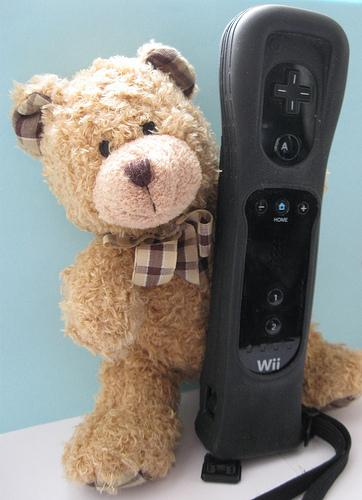What kind of game controller is being held by the bear, and what are its distinctive characteristics? The bear is holding a black wii game controller with a strap, white lettering that says "wii", and a round home button with a blue icon. Mention the various objects in the image along with their colors and specific details. The image consists of a beige teddy bear with plaid ears and a bow tie, a black wii game controller with a strap and white lettering, and a gray wii console. What is the bear wearing around its neck, and describe the bear's other distinct features. The bear is wearing a plaid ribbon around its neck. It has dark button eyes, a brown nose, and plaid ears. Choose an object in the image and talk about its distinguishing characteristics. The black wii game controller has white lettering that says "wii", a round home button with a blue icon, and a black strap. Identify the color and type of the object the bear is holding and describe the bear's appearance. The bear is holding a black wii game controller. It has brown fur, plaid ears, a pink snout, black eyes, and a plaid ribbon. Explain the type of scarf the bear is wearing and describe its appearance. The bear is wearing a plaid ribbon scarf around its neck. It is yellow and brown in color with a distinct plaid pattern. What does the lettering on the controller say, and what is its color? The lettering on the controller says "wii" and is white in color. Discuss the appearance of the teddy bear in the image, including its color, facial features, and any accessories. The teddy bear is beige with dark button eyes, a brown nose, plaid ears, and a yellow and brown bow tie around its neck. Describe the special features of the controller held by the bear. The controller has a round home button with a blue icon, number 1 and 2 buttons, a wrist band, and is in a black case. 